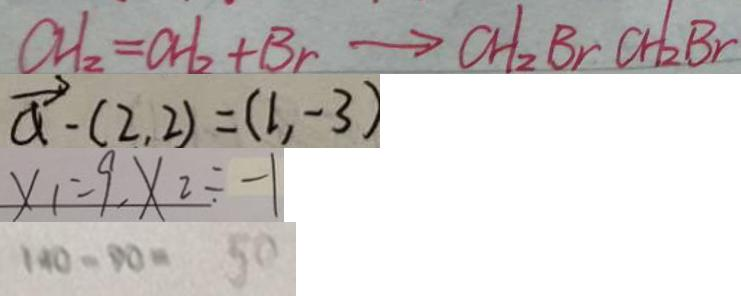Convert formula to latex. <formula><loc_0><loc_0><loc_500><loc_500>C H _ { 2 } = C H _ { 2 } + B r \rightarrow C H _ { 2 } B r C H _ { 2 } B r 
 \overrightarrow { a } - ( 2 , 2 ) = ( 1 , - 3 ) 
 x _ { 1 } = 9 , X _ { 2 } \div - 1 
 1 4 0 - 9 0 = 5 0</formula> 